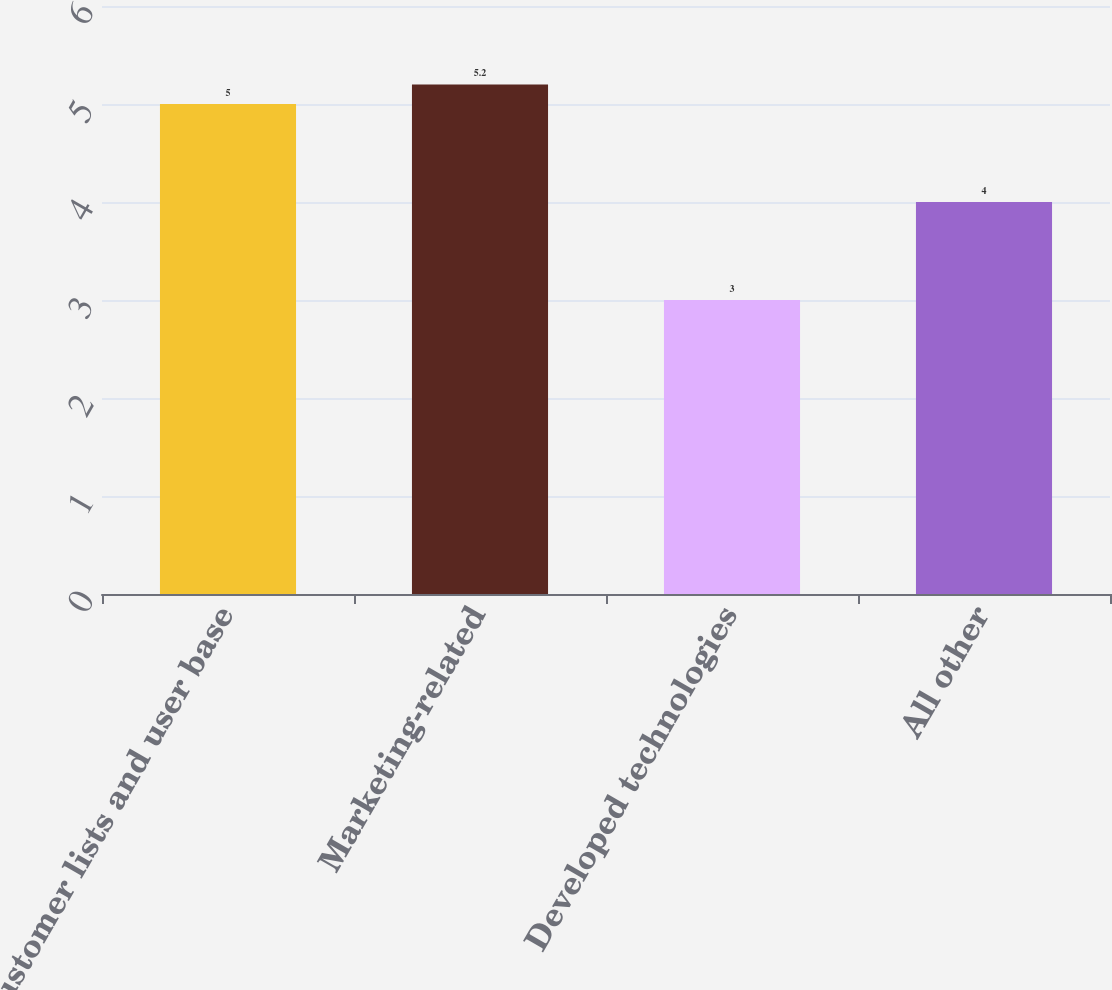Convert chart. <chart><loc_0><loc_0><loc_500><loc_500><bar_chart><fcel>Customer lists and user base<fcel>Marketing-related<fcel>Developed technologies<fcel>All other<nl><fcel>5<fcel>5.2<fcel>3<fcel>4<nl></chart> 